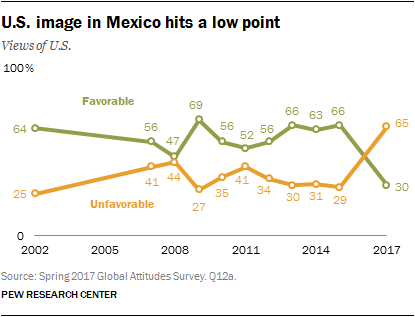Could you explain what factors might have contributed to the peaks and troughs in the U.S.'s favorability rating in Mexico? Various factors can account for the peaks and troughs in the U.S.'s favorability rating in Mexico. Political leadership changes in either country, policies affecting immigration and trade, cultural exchanges, diplomatic incidents, as well as economic circumstances could all influence public opinion. Specific events such as elections, the implementation of trade agreements or tariffs, changes in migration law, and shifts in foreign policy can all lead to changes in how citizens of one country view another. 